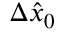<formula> <loc_0><loc_0><loc_500><loc_500>\Delta \hat { x } _ { 0 }</formula> 